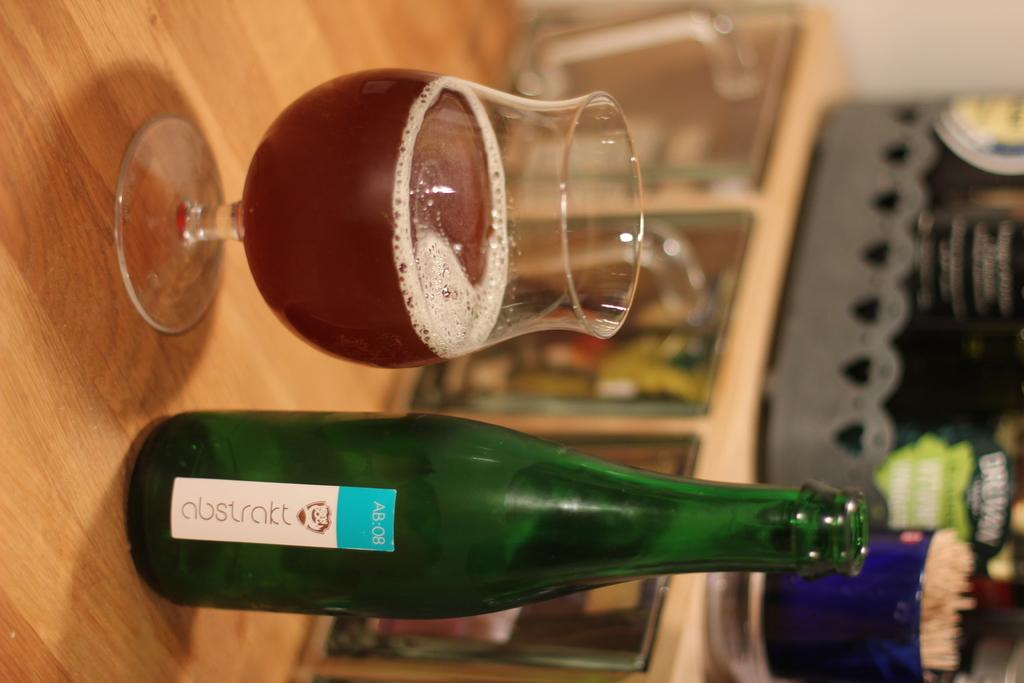<image>
Summarize the visual content of the image. the word abstrakt is on the green bottle next to a glass 